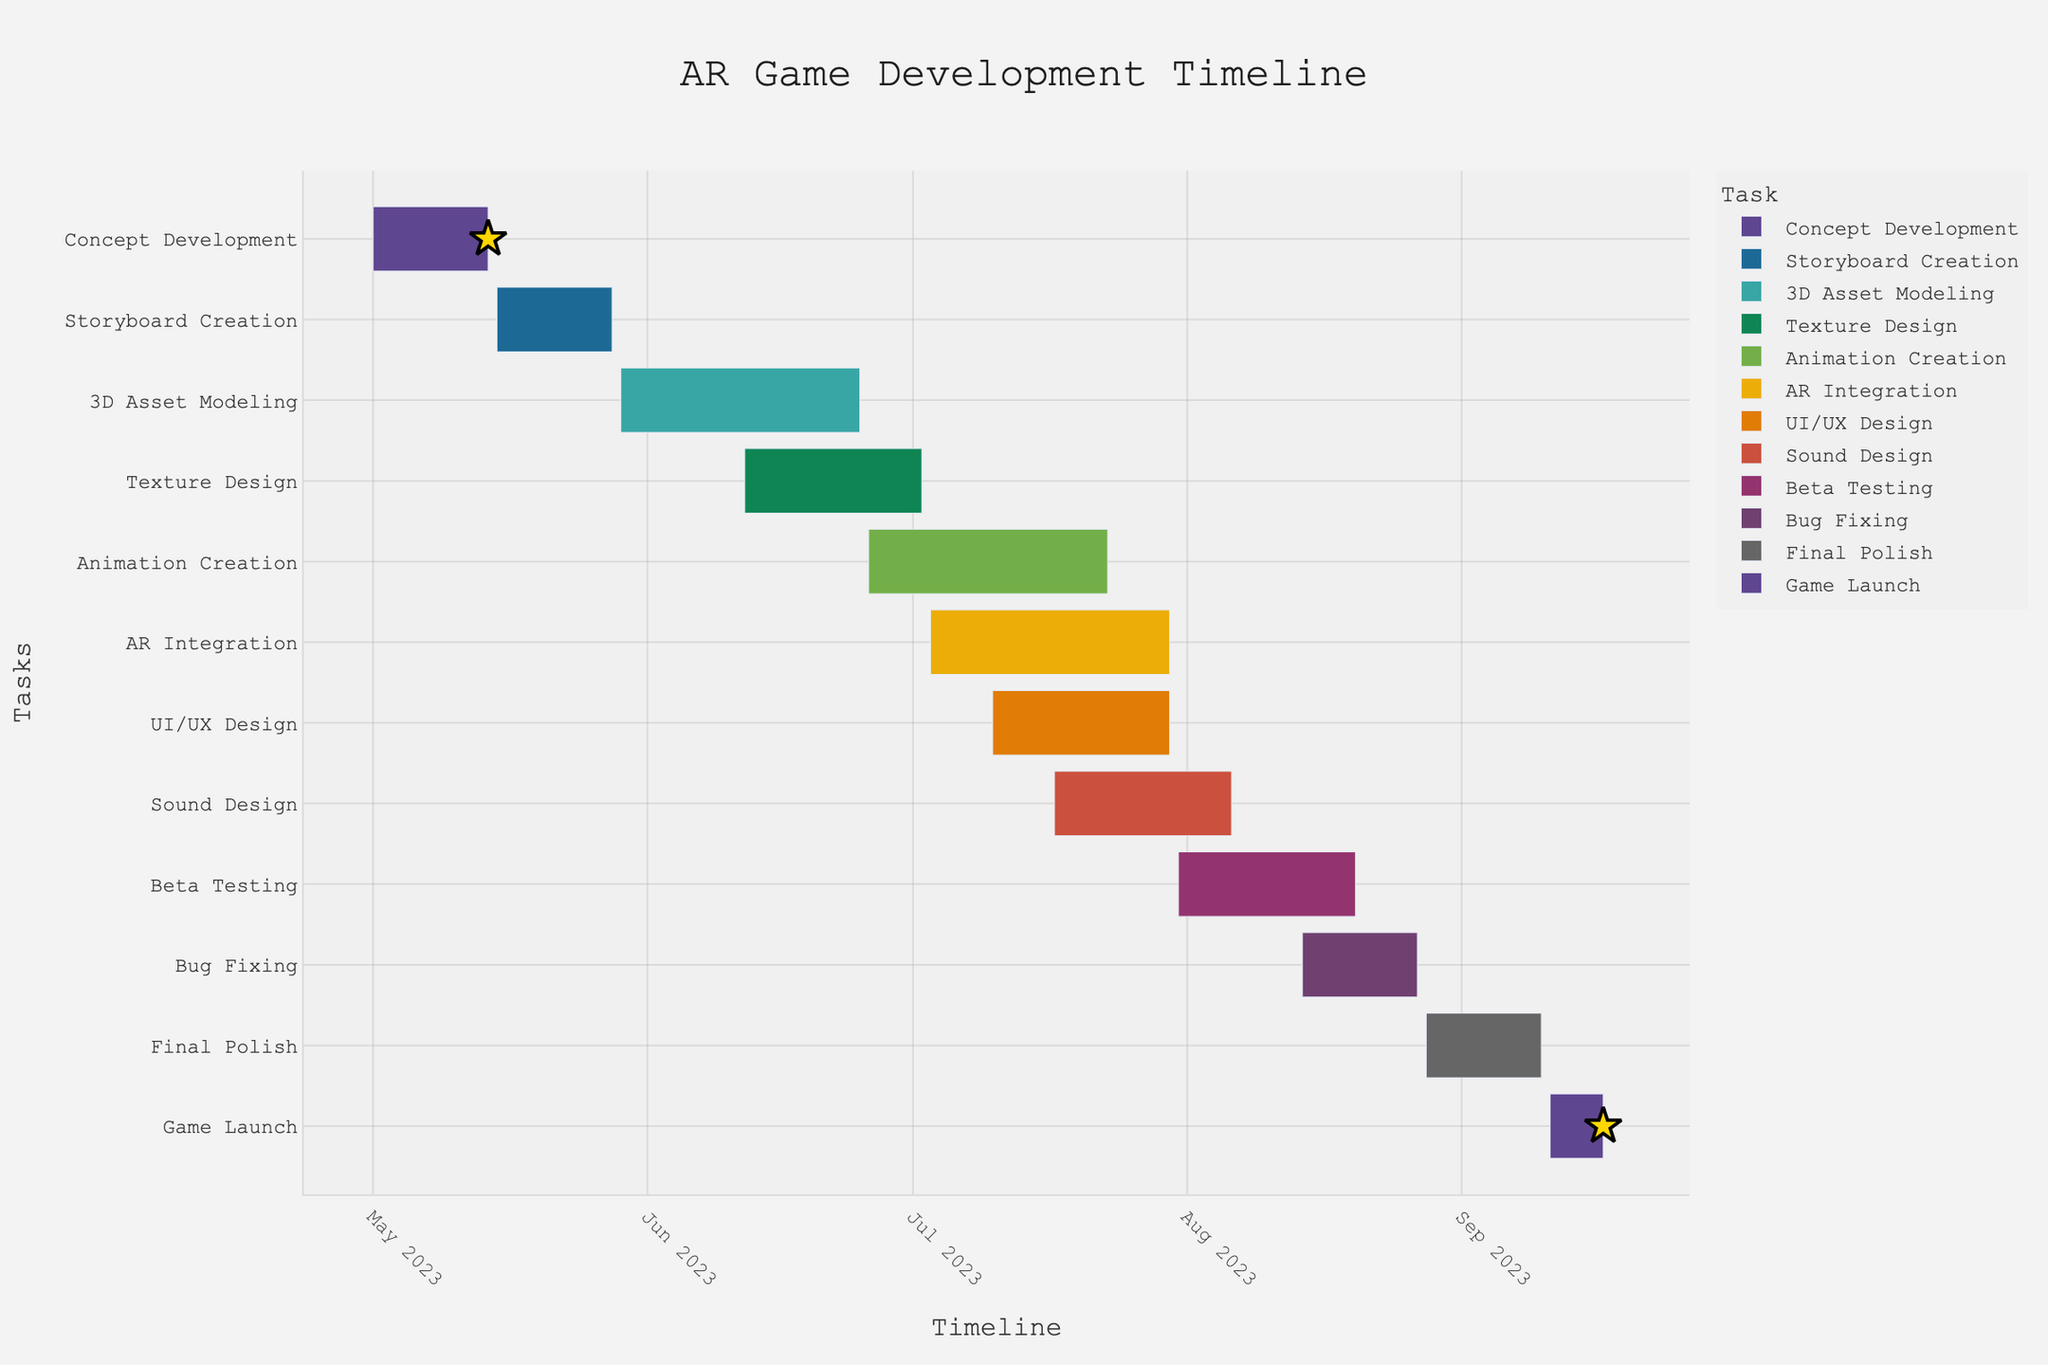What is the title of the Gantt Chart? The title is usually found at the top of the chart and serves to describe the overall subject of the chart. The title text is "AR Game Development Timeline" as specified in the `title` attribute of the plot layout.
Answer: AR Game Development Timeline When does the 'AR Integration' task start and end? Look for the 'AR Integration' task in the Y-axis labels, then follow the bar horizontally to find its endpoints on the X-axis. The 'AR Integration' task starts on July 3, 2023, and ends on July 30, 2023.
Answer: Starts July 3, 2023, and ends July 30, 2023 How long is the '3D Asset Modeling' phase, and how does it compare to the 'Texture Design' phase in terms of duration? Identify the '3D Asset Modeling' and 'Texture Design' tasks on the Y-axis and look at their corresponding durations. '3D Asset Modeling' duration is 28 days which can be directly compared to 'Texture Design's 21 days by subtracting the latter from the former.
Answer: '3D Asset Modeling' is 7 days longer Which task has the shortest duration, and how long is it? Observe the length of each task's bar. The task with the shortest bar is 'Game Launch'. The duration of 'Game Launch' is 7 days.
Answer: Game Launch, 7 days Which two tasks overlap in their timeframes? Check for parallel bars on the chart that start and end within the same periods. For example, 'Sound Design' (July 17, 2023 - August 6, 2023) overlaps with 'Beta Testing' (July 31, 2023 - August 20, 2023).
Answer: Sound Design and Beta Testing What milestone marks the start of the project and which marks the end? Look for markers indicating milestones, usually noted by a star symbol or special mark. The 'Concept Development' marks the start and 'Game Launch' marks the end.
Answer: Concept Development starts, Game Launch ends How many days is there between the end of 'Bug Fixing' and the start of 'Final Polish'? Note the end date of 'Bug Fixing' and the start date of 'Final Polish'. Count the days in between. 'Bug Fixing' ends on August 27, 2023, and 'Final Polish' starts on August 28, 2023, yielding a 1-day gap.
Answer: 1 day Which task takes place entirely during the month of July 2023? Identify tasks that start and end within July 2023 by their positions on the X-axis. 'UI/UX Design' starts on July 10 and ends on July 30, making it the task that occurs entirely in July.
Answer: UI/UX Design What's the total duration for tasks starting in May 2023? Sum the durations of the tasks that begin in May: 'Concept Development' (May 1 - May 14), 'Storyboard Creation' (May 15 - May 28), and '3D Asset Modeling' (starts May 29). Their durations are 14, 14, and 28 days respectively. Hence, 14 + 14 + 28 = 56 days.
Answer: 56 days 